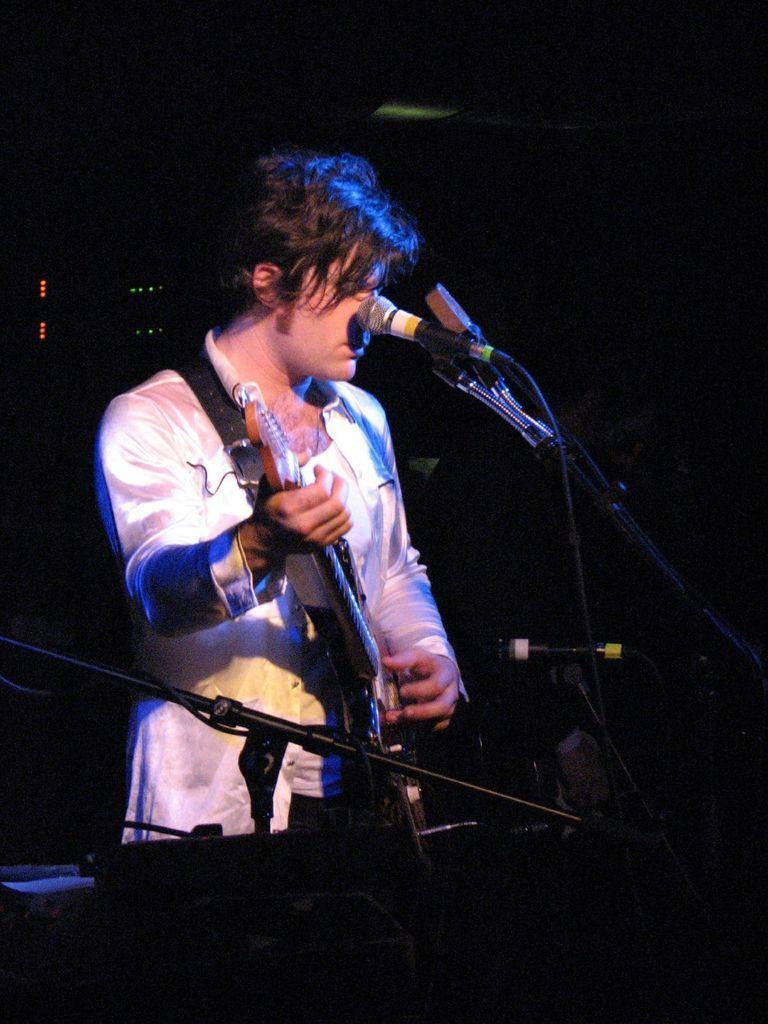Can you describe this image briefly? In this image the background is dark. In the middle of the image a man is standing and he is holding a guitar in his hands and he is playing music. There is a mic and there are a few objects. 